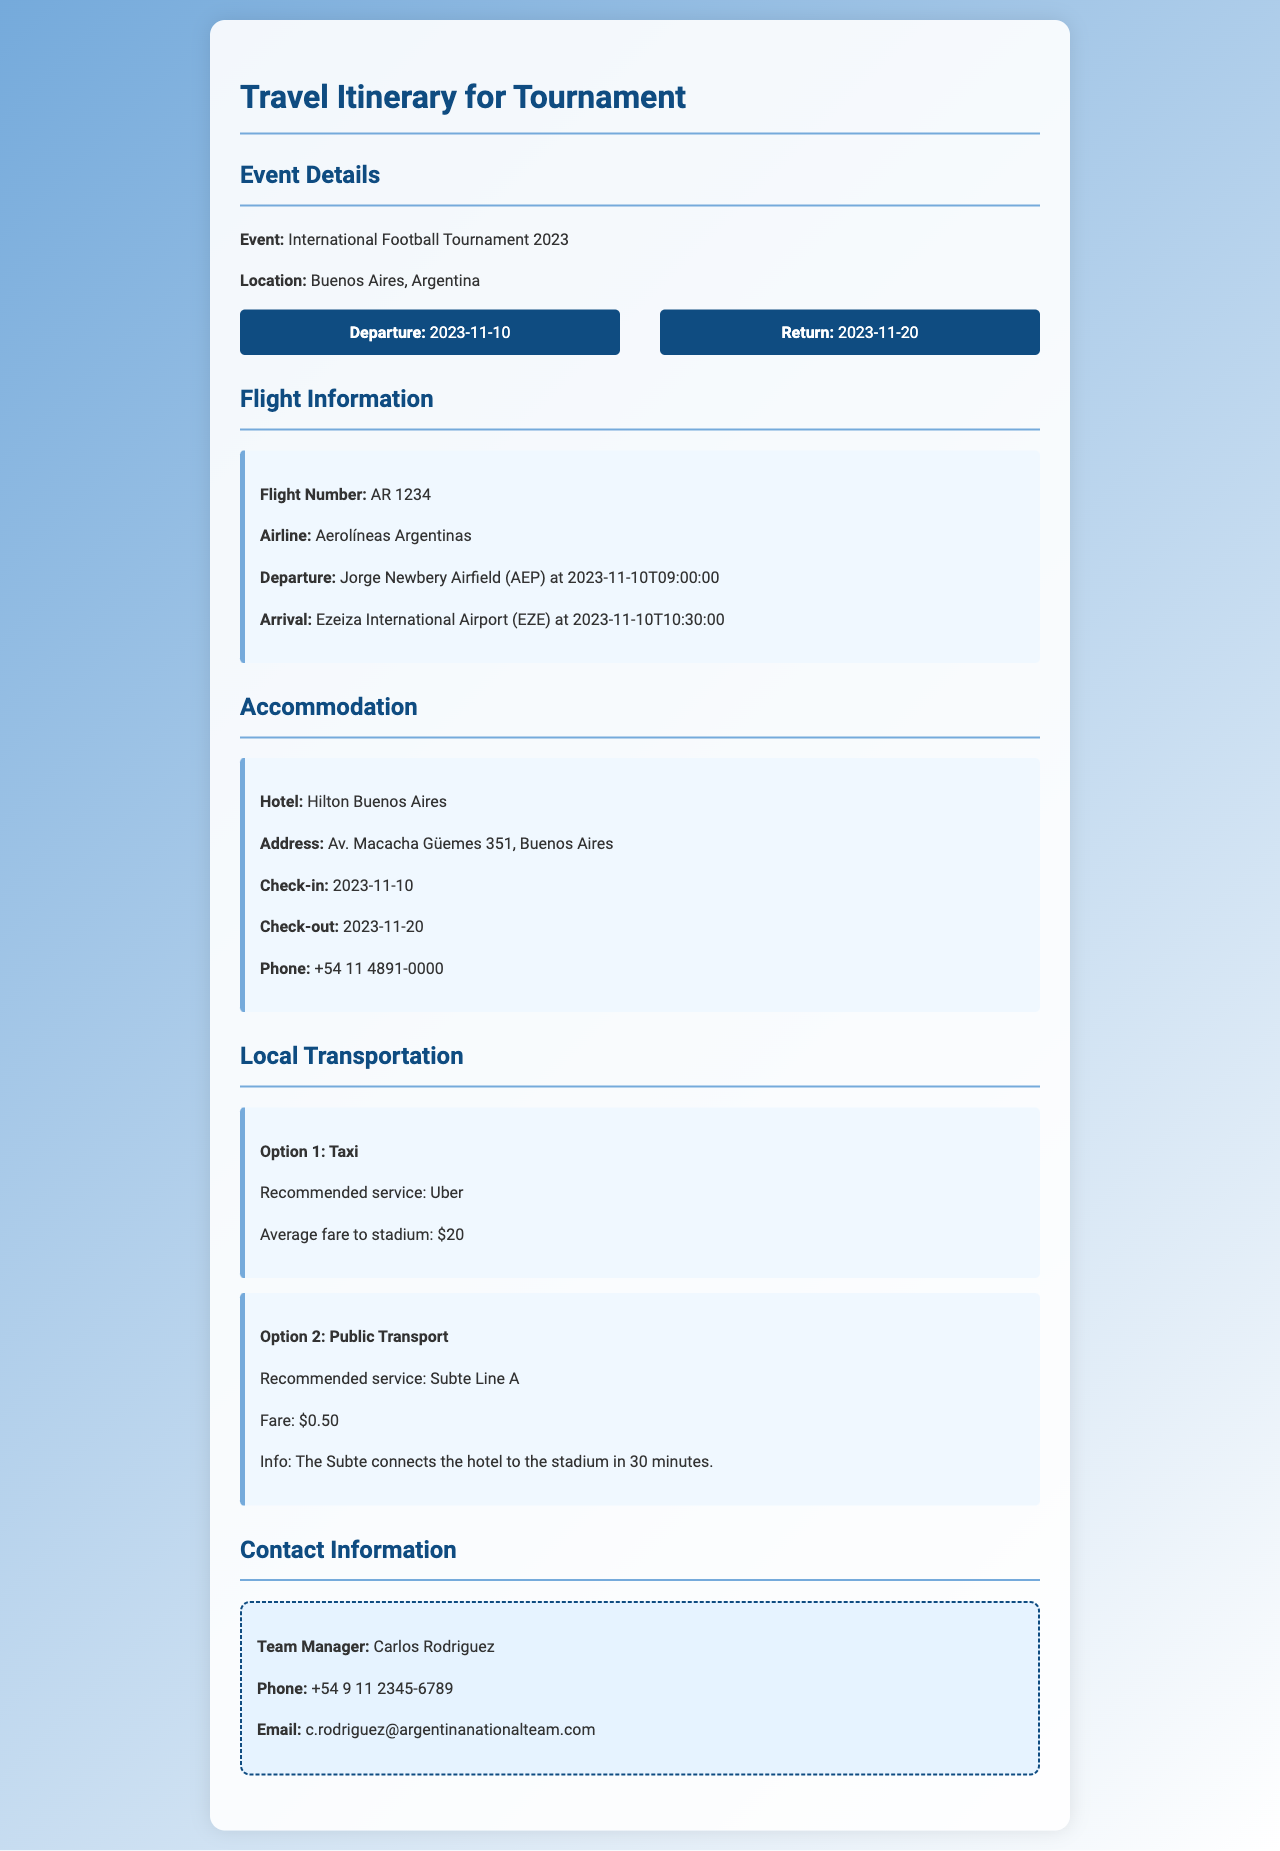What is the event name? The event name is stated in the document under Event Details.
Answer: International Football Tournament 2023 When is the check-out date? The check-out date is specified in the Accommodation section.
Answer: 2023-11-20 What is the flight number? The flight number is provided in the Flight Information section.
Answer: AR 1234 What is the average fare for a taxi to the stadium? The average fare is mentioned under Local Transportation, specifically for the Taxi option.
Answer: $20 Which Subte line connects the hotel to the stadium? The document specifies the recommended Subte line under the Public Transport option.
Answer: Line A Who is the team manager? The team manager's name is listed in the Contact Information section.
Answer: Carlos Rodriguez What is the name of the hotel? The hotel's name is stated in the Accommodation section.
Answer: Hilton Buenos Aires What time does the flight depart? The departure time is indicated in the Flight Information section.
Answer: 09:00 How long is the flight's duration? The duration is derived from the departure and arrival times in the Flight Information section.
Answer: 1 hour 30 minutes 